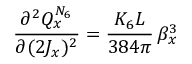Convert formula to latex. <formula><loc_0><loc_0><loc_500><loc_500>\frac { \partial ^ { 2 } Q _ { x } ^ { N _ { 6 } } } { \partial ( 2 J _ { x } ) ^ { 2 } } = \frac { K _ { 6 } L } { 3 8 4 \pi } \, \beta _ { x } ^ { 3 }</formula> 